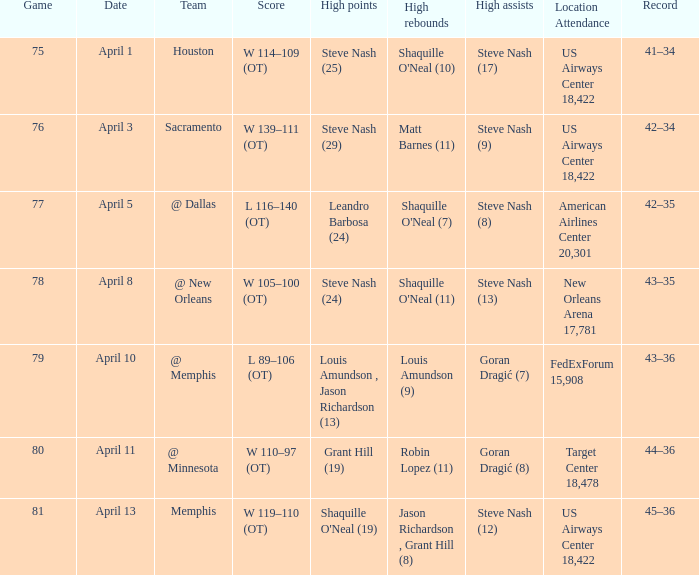What was the team's score on April 1? W 114–109 (OT). 